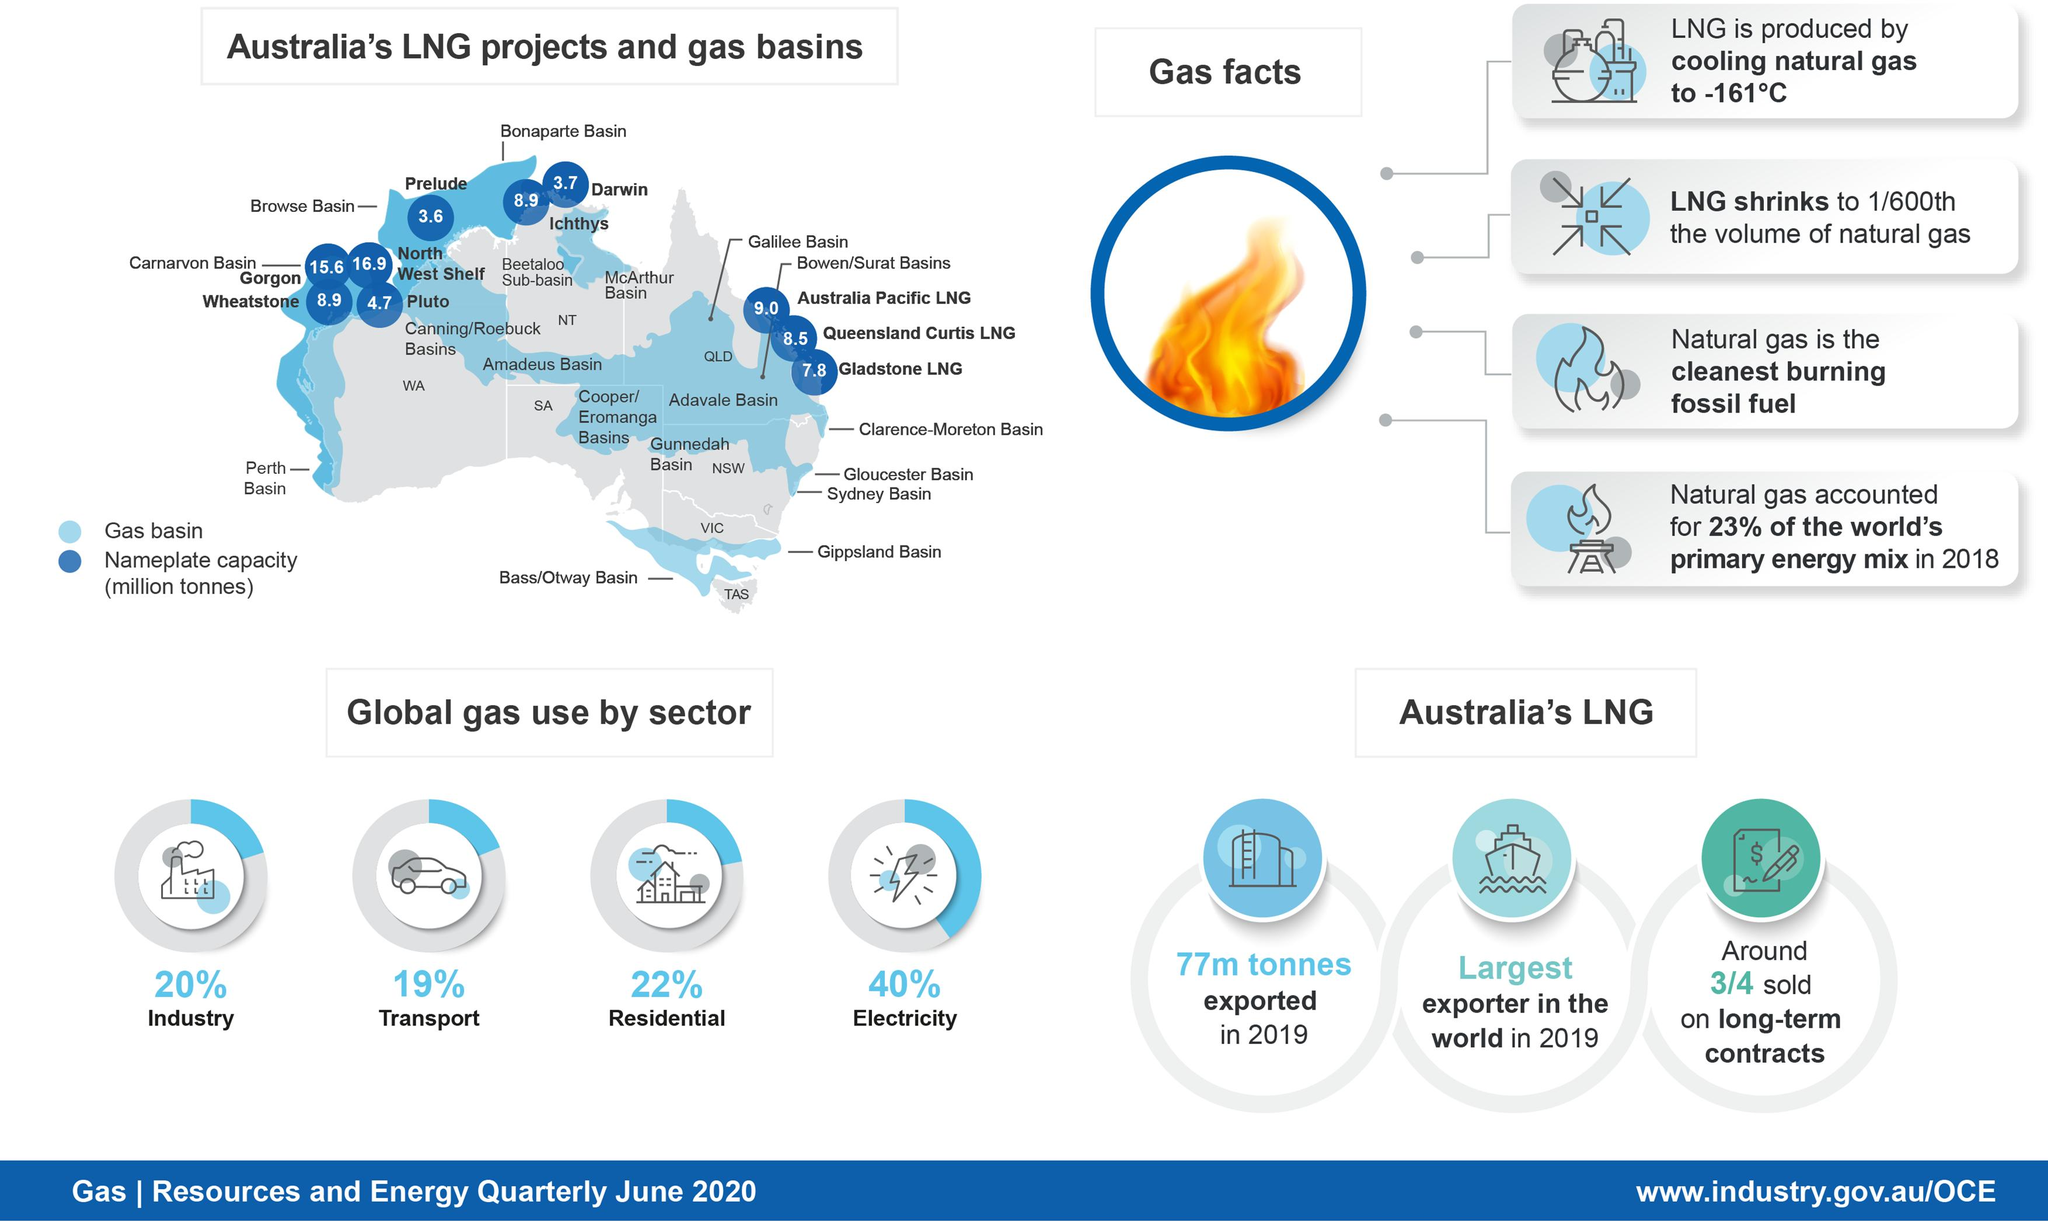Point out several critical features in this image. The residential sector globally uses 22% of natural gas. The Wheatstone LNG project produces approximately 8.9 million tonnes of LNG per year. In the global industrial sector, natural gas accounts for 20% of its total use. The Gorgon LNG project produces approximately 15.6 million tonnes of LNG per year. In 2019, Australia exported a total of 77 million tonnes of LNG. 